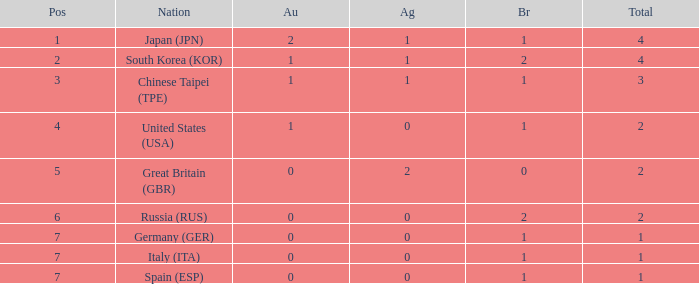What is the rank of the country with more than 2 medals, and 2 gold medals? 1.0. 